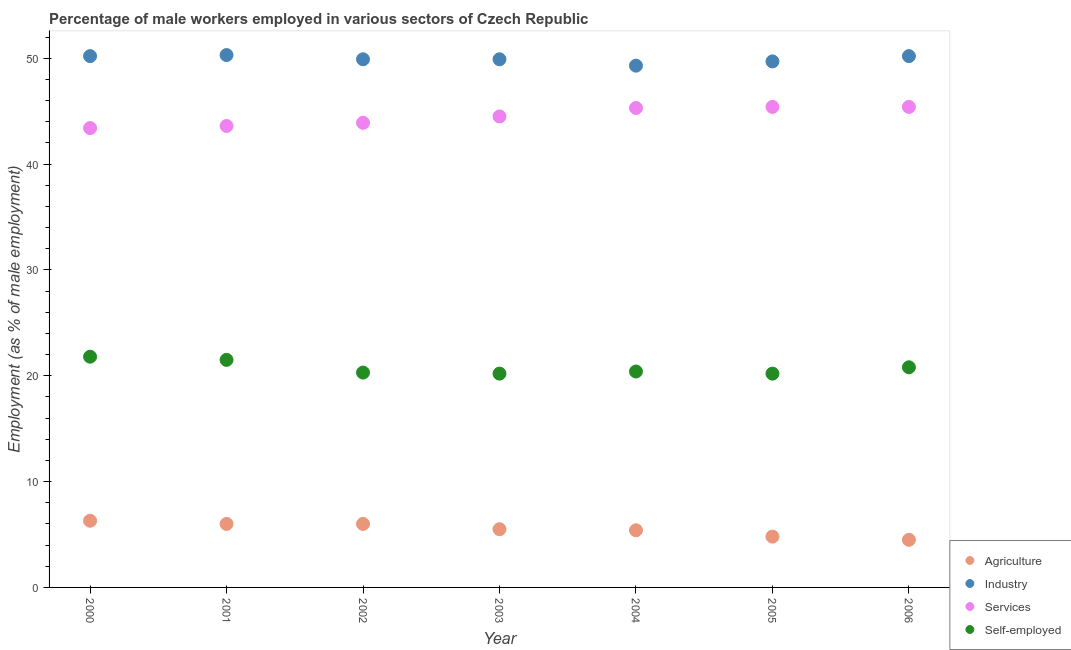What is the percentage of male workers in agriculture in 2005?
Provide a succinct answer. 4.8. Across all years, what is the maximum percentage of self employed male workers?
Provide a succinct answer. 21.8. Across all years, what is the minimum percentage of male workers in services?
Ensure brevity in your answer.  43.4. What is the total percentage of male workers in agriculture in the graph?
Your answer should be very brief. 38.5. What is the difference between the percentage of male workers in services in 2003 and the percentage of male workers in agriculture in 2001?
Provide a succinct answer. 38.5. What is the average percentage of male workers in industry per year?
Offer a terse response. 49.93. In the year 2001, what is the difference between the percentage of male workers in industry and percentage of self employed male workers?
Keep it short and to the point. 28.8. In how many years, is the percentage of male workers in agriculture greater than 32 %?
Make the answer very short. 0. What is the ratio of the percentage of male workers in services in 2001 to that in 2003?
Offer a very short reply. 0.98. Is the percentage of male workers in agriculture in 2000 less than that in 2005?
Your response must be concise. No. What is the difference between the highest and the second highest percentage of male workers in agriculture?
Offer a terse response. 0.3. What is the difference between the highest and the lowest percentage of self employed male workers?
Ensure brevity in your answer.  1.6. In how many years, is the percentage of self employed male workers greater than the average percentage of self employed male workers taken over all years?
Your answer should be very brief. 3. Does the percentage of male workers in industry monotonically increase over the years?
Your answer should be compact. No. Is the percentage of male workers in industry strictly less than the percentage of male workers in services over the years?
Offer a very short reply. No. How many dotlines are there?
Your response must be concise. 4. Are the values on the major ticks of Y-axis written in scientific E-notation?
Keep it short and to the point. No. Does the graph contain grids?
Provide a succinct answer. No. How many legend labels are there?
Give a very brief answer. 4. What is the title of the graph?
Your answer should be compact. Percentage of male workers employed in various sectors of Czech Republic. Does "Primary education" appear as one of the legend labels in the graph?
Give a very brief answer. No. What is the label or title of the Y-axis?
Offer a terse response. Employment (as % of male employment). What is the Employment (as % of male employment) in Agriculture in 2000?
Provide a short and direct response. 6.3. What is the Employment (as % of male employment) of Industry in 2000?
Your answer should be compact. 50.2. What is the Employment (as % of male employment) of Services in 2000?
Make the answer very short. 43.4. What is the Employment (as % of male employment) of Self-employed in 2000?
Provide a short and direct response. 21.8. What is the Employment (as % of male employment) of Industry in 2001?
Keep it short and to the point. 50.3. What is the Employment (as % of male employment) of Services in 2001?
Make the answer very short. 43.6. What is the Employment (as % of male employment) of Self-employed in 2001?
Give a very brief answer. 21.5. What is the Employment (as % of male employment) of Agriculture in 2002?
Keep it short and to the point. 6. What is the Employment (as % of male employment) of Industry in 2002?
Your answer should be compact. 49.9. What is the Employment (as % of male employment) in Services in 2002?
Provide a succinct answer. 43.9. What is the Employment (as % of male employment) of Self-employed in 2002?
Give a very brief answer. 20.3. What is the Employment (as % of male employment) of Agriculture in 2003?
Your response must be concise. 5.5. What is the Employment (as % of male employment) of Industry in 2003?
Keep it short and to the point. 49.9. What is the Employment (as % of male employment) in Services in 2003?
Ensure brevity in your answer.  44.5. What is the Employment (as % of male employment) of Self-employed in 2003?
Offer a terse response. 20.2. What is the Employment (as % of male employment) of Agriculture in 2004?
Your answer should be very brief. 5.4. What is the Employment (as % of male employment) of Industry in 2004?
Provide a short and direct response. 49.3. What is the Employment (as % of male employment) of Services in 2004?
Offer a terse response. 45.3. What is the Employment (as % of male employment) in Self-employed in 2004?
Make the answer very short. 20.4. What is the Employment (as % of male employment) of Agriculture in 2005?
Ensure brevity in your answer.  4.8. What is the Employment (as % of male employment) in Industry in 2005?
Offer a very short reply. 49.7. What is the Employment (as % of male employment) in Services in 2005?
Make the answer very short. 45.4. What is the Employment (as % of male employment) of Self-employed in 2005?
Offer a very short reply. 20.2. What is the Employment (as % of male employment) in Industry in 2006?
Offer a terse response. 50.2. What is the Employment (as % of male employment) of Services in 2006?
Your response must be concise. 45.4. What is the Employment (as % of male employment) in Self-employed in 2006?
Offer a very short reply. 20.8. Across all years, what is the maximum Employment (as % of male employment) of Agriculture?
Your response must be concise. 6.3. Across all years, what is the maximum Employment (as % of male employment) of Industry?
Offer a very short reply. 50.3. Across all years, what is the maximum Employment (as % of male employment) in Services?
Offer a terse response. 45.4. Across all years, what is the maximum Employment (as % of male employment) of Self-employed?
Provide a short and direct response. 21.8. Across all years, what is the minimum Employment (as % of male employment) in Agriculture?
Your answer should be very brief. 4.5. Across all years, what is the minimum Employment (as % of male employment) of Industry?
Your answer should be very brief. 49.3. Across all years, what is the minimum Employment (as % of male employment) in Services?
Your answer should be compact. 43.4. Across all years, what is the minimum Employment (as % of male employment) of Self-employed?
Offer a terse response. 20.2. What is the total Employment (as % of male employment) in Agriculture in the graph?
Your answer should be very brief. 38.5. What is the total Employment (as % of male employment) of Industry in the graph?
Provide a succinct answer. 349.5. What is the total Employment (as % of male employment) of Services in the graph?
Offer a terse response. 311.5. What is the total Employment (as % of male employment) of Self-employed in the graph?
Offer a terse response. 145.2. What is the difference between the Employment (as % of male employment) in Agriculture in 2000 and that in 2001?
Offer a terse response. 0.3. What is the difference between the Employment (as % of male employment) of Industry in 2000 and that in 2001?
Ensure brevity in your answer.  -0.1. What is the difference between the Employment (as % of male employment) in Services in 2000 and that in 2001?
Provide a short and direct response. -0.2. What is the difference between the Employment (as % of male employment) in Agriculture in 2000 and that in 2002?
Ensure brevity in your answer.  0.3. What is the difference between the Employment (as % of male employment) in Industry in 2000 and that in 2002?
Provide a succinct answer. 0.3. What is the difference between the Employment (as % of male employment) of Services in 2000 and that in 2002?
Your answer should be compact. -0.5. What is the difference between the Employment (as % of male employment) of Self-employed in 2000 and that in 2002?
Keep it short and to the point. 1.5. What is the difference between the Employment (as % of male employment) of Agriculture in 2000 and that in 2003?
Your response must be concise. 0.8. What is the difference between the Employment (as % of male employment) in Industry in 2000 and that in 2003?
Offer a terse response. 0.3. What is the difference between the Employment (as % of male employment) in Self-employed in 2000 and that in 2004?
Give a very brief answer. 1.4. What is the difference between the Employment (as % of male employment) in Agriculture in 2000 and that in 2005?
Your response must be concise. 1.5. What is the difference between the Employment (as % of male employment) of Services in 2000 and that in 2005?
Your response must be concise. -2. What is the difference between the Employment (as % of male employment) of Self-employed in 2000 and that in 2005?
Provide a short and direct response. 1.6. What is the difference between the Employment (as % of male employment) of Agriculture in 2000 and that in 2006?
Make the answer very short. 1.8. What is the difference between the Employment (as % of male employment) in Services in 2000 and that in 2006?
Offer a very short reply. -2. What is the difference between the Employment (as % of male employment) in Industry in 2001 and that in 2002?
Give a very brief answer. 0.4. What is the difference between the Employment (as % of male employment) of Services in 2001 and that in 2002?
Give a very brief answer. -0.3. What is the difference between the Employment (as % of male employment) in Self-employed in 2001 and that in 2002?
Keep it short and to the point. 1.2. What is the difference between the Employment (as % of male employment) in Agriculture in 2001 and that in 2004?
Give a very brief answer. 0.6. What is the difference between the Employment (as % of male employment) of Services in 2001 and that in 2005?
Give a very brief answer. -1.8. What is the difference between the Employment (as % of male employment) in Industry in 2001 and that in 2006?
Provide a succinct answer. 0.1. What is the difference between the Employment (as % of male employment) of Services in 2001 and that in 2006?
Make the answer very short. -1.8. What is the difference between the Employment (as % of male employment) of Agriculture in 2002 and that in 2003?
Offer a terse response. 0.5. What is the difference between the Employment (as % of male employment) of Industry in 2002 and that in 2004?
Offer a terse response. 0.6. What is the difference between the Employment (as % of male employment) in Self-employed in 2002 and that in 2004?
Your answer should be very brief. -0.1. What is the difference between the Employment (as % of male employment) in Agriculture in 2002 and that in 2005?
Provide a short and direct response. 1.2. What is the difference between the Employment (as % of male employment) in Services in 2002 and that in 2005?
Your response must be concise. -1.5. What is the difference between the Employment (as % of male employment) in Self-employed in 2002 and that in 2005?
Your answer should be very brief. 0.1. What is the difference between the Employment (as % of male employment) in Services in 2002 and that in 2006?
Give a very brief answer. -1.5. What is the difference between the Employment (as % of male employment) in Self-employed in 2002 and that in 2006?
Your answer should be very brief. -0.5. What is the difference between the Employment (as % of male employment) in Agriculture in 2003 and that in 2004?
Your response must be concise. 0.1. What is the difference between the Employment (as % of male employment) in Industry in 2003 and that in 2004?
Your answer should be very brief. 0.6. What is the difference between the Employment (as % of male employment) in Services in 2003 and that in 2004?
Your answer should be compact. -0.8. What is the difference between the Employment (as % of male employment) in Self-employed in 2003 and that in 2004?
Your answer should be very brief. -0.2. What is the difference between the Employment (as % of male employment) of Agriculture in 2003 and that in 2005?
Offer a very short reply. 0.7. What is the difference between the Employment (as % of male employment) in Self-employed in 2003 and that in 2005?
Ensure brevity in your answer.  0. What is the difference between the Employment (as % of male employment) of Services in 2003 and that in 2006?
Provide a succinct answer. -0.9. What is the difference between the Employment (as % of male employment) of Self-employed in 2003 and that in 2006?
Ensure brevity in your answer.  -0.6. What is the difference between the Employment (as % of male employment) in Agriculture in 2004 and that in 2005?
Give a very brief answer. 0.6. What is the difference between the Employment (as % of male employment) of Industry in 2004 and that in 2005?
Your response must be concise. -0.4. What is the difference between the Employment (as % of male employment) in Self-employed in 2004 and that in 2005?
Your response must be concise. 0.2. What is the difference between the Employment (as % of male employment) in Agriculture in 2004 and that in 2006?
Keep it short and to the point. 0.9. What is the difference between the Employment (as % of male employment) in Self-employed in 2004 and that in 2006?
Make the answer very short. -0.4. What is the difference between the Employment (as % of male employment) of Agriculture in 2005 and that in 2006?
Offer a very short reply. 0.3. What is the difference between the Employment (as % of male employment) of Industry in 2005 and that in 2006?
Offer a very short reply. -0.5. What is the difference between the Employment (as % of male employment) in Agriculture in 2000 and the Employment (as % of male employment) in Industry in 2001?
Your answer should be very brief. -44. What is the difference between the Employment (as % of male employment) in Agriculture in 2000 and the Employment (as % of male employment) in Services in 2001?
Offer a very short reply. -37.3. What is the difference between the Employment (as % of male employment) in Agriculture in 2000 and the Employment (as % of male employment) in Self-employed in 2001?
Your response must be concise. -15.2. What is the difference between the Employment (as % of male employment) of Industry in 2000 and the Employment (as % of male employment) of Services in 2001?
Your answer should be very brief. 6.6. What is the difference between the Employment (as % of male employment) of Industry in 2000 and the Employment (as % of male employment) of Self-employed in 2001?
Give a very brief answer. 28.7. What is the difference between the Employment (as % of male employment) of Services in 2000 and the Employment (as % of male employment) of Self-employed in 2001?
Keep it short and to the point. 21.9. What is the difference between the Employment (as % of male employment) of Agriculture in 2000 and the Employment (as % of male employment) of Industry in 2002?
Offer a very short reply. -43.6. What is the difference between the Employment (as % of male employment) in Agriculture in 2000 and the Employment (as % of male employment) in Services in 2002?
Ensure brevity in your answer.  -37.6. What is the difference between the Employment (as % of male employment) in Agriculture in 2000 and the Employment (as % of male employment) in Self-employed in 2002?
Provide a succinct answer. -14. What is the difference between the Employment (as % of male employment) in Industry in 2000 and the Employment (as % of male employment) in Self-employed in 2002?
Your answer should be compact. 29.9. What is the difference between the Employment (as % of male employment) in Services in 2000 and the Employment (as % of male employment) in Self-employed in 2002?
Give a very brief answer. 23.1. What is the difference between the Employment (as % of male employment) in Agriculture in 2000 and the Employment (as % of male employment) in Industry in 2003?
Provide a short and direct response. -43.6. What is the difference between the Employment (as % of male employment) in Agriculture in 2000 and the Employment (as % of male employment) in Services in 2003?
Ensure brevity in your answer.  -38.2. What is the difference between the Employment (as % of male employment) of Industry in 2000 and the Employment (as % of male employment) of Services in 2003?
Make the answer very short. 5.7. What is the difference between the Employment (as % of male employment) in Services in 2000 and the Employment (as % of male employment) in Self-employed in 2003?
Provide a short and direct response. 23.2. What is the difference between the Employment (as % of male employment) in Agriculture in 2000 and the Employment (as % of male employment) in Industry in 2004?
Ensure brevity in your answer.  -43. What is the difference between the Employment (as % of male employment) of Agriculture in 2000 and the Employment (as % of male employment) of Services in 2004?
Keep it short and to the point. -39. What is the difference between the Employment (as % of male employment) in Agriculture in 2000 and the Employment (as % of male employment) in Self-employed in 2004?
Your answer should be very brief. -14.1. What is the difference between the Employment (as % of male employment) in Industry in 2000 and the Employment (as % of male employment) in Services in 2004?
Ensure brevity in your answer.  4.9. What is the difference between the Employment (as % of male employment) of Industry in 2000 and the Employment (as % of male employment) of Self-employed in 2004?
Offer a terse response. 29.8. What is the difference between the Employment (as % of male employment) of Services in 2000 and the Employment (as % of male employment) of Self-employed in 2004?
Make the answer very short. 23. What is the difference between the Employment (as % of male employment) of Agriculture in 2000 and the Employment (as % of male employment) of Industry in 2005?
Make the answer very short. -43.4. What is the difference between the Employment (as % of male employment) of Agriculture in 2000 and the Employment (as % of male employment) of Services in 2005?
Offer a very short reply. -39.1. What is the difference between the Employment (as % of male employment) in Agriculture in 2000 and the Employment (as % of male employment) in Self-employed in 2005?
Give a very brief answer. -13.9. What is the difference between the Employment (as % of male employment) in Industry in 2000 and the Employment (as % of male employment) in Self-employed in 2005?
Provide a succinct answer. 30. What is the difference between the Employment (as % of male employment) of Services in 2000 and the Employment (as % of male employment) of Self-employed in 2005?
Provide a succinct answer. 23.2. What is the difference between the Employment (as % of male employment) of Agriculture in 2000 and the Employment (as % of male employment) of Industry in 2006?
Offer a terse response. -43.9. What is the difference between the Employment (as % of male employment) in Agriculture in 2000 and the Employment (as % of male employment) in Services in 2006?
Your response must be concise. -39.1. What is the difference between the Employment (as % of male employment) in Industry in 2000 and the Employment (as % of male employment) in Services in 2006?
Your answer should be very brief. 4.8. What is the difference between the Employment (as % of male employment) in Industry in 2000 and the Employment (as % of male employment) in Self-employed in 2006?
Your response must be concise. 29.4. What is the difference between the Employment (as % of male employment) in Services in 2000 and the Employment (as % of male employment) in Self-employed in 2006?
Give a very brief answer. 22.6. What is the difference between the Employment (as % of male employment) of Agriculture in 2001 and the Employment (as % of male employment) of Industry in 2002?
Your answer should be compact. -43.9. What is the difference between the Employment (as % of male employment) in Agriculture in 2001 and the Employment (as % of male employment) in Services in 2002?
Provide a succinct answer. -37.9. What is the difference between the Employment (as % of male employment) in Agriculture in 2001 and the Employment (as % of male employment) in Self-employed in 2002?
Offer a terse response. -14.3. What is the difference between the Employment (as % of male employment) of Industry in 2001 and the Employment (as % of male employment) of Services in 2002?
Ensure brevity in your answer.  6.4. What is the difference between the Employment (as % of male employment) in Industry in 2001 and the Employment (as % of male employment) in Self-employed in 2002?
Offer a very short reply. 30. What is the difference between the Employment (as % of male employment) of Services in 2001 and the Employment (as % of male employment) of Self-employed in 2002?
Give a very brief answer. 23.3. What is the difference between the Employment (as % of male employment) of Agriculture in 2001 and the Employment (as % of male employment) of Industry in 2003?
Provide a succinct answer. -43.9. What is the difference between the Employment (as % of male employment) in Agriculture in 2001 and the Employment (as % of male employment) in Services in 2003?
Ensure brevity in your answer.  -38.5. What is the difference between the Employment (as % of male employment) in Agriculture in 2001 and the Employment (as % of male employment) in Self-employed in 2003?
Your answer should be very brief. -14.2. What is the difference between the Employment (as % of male employment) of Industry in 2001 and the Employment (as % of male employment) of Services in 2003?
Offer a terse response. 5.8. What is the difference between the Employment (as % of male employment) of Industry in 2001 and the Employment (as % of male employment) of Self-employed in 2003?
Your answer should be very brief. 30.1. What is the difference between the Employment (as % of male employment) in Services in 2001 and the Employment (as % of male employment) in Self-employed in 2003?
Make the answer very short. 23.4. What is the difference between the Employment (as % of male employment) of Agriculture in 2001 and the Employment (as % of male employment) of Industry in 2004?
Ensure brevity in your answer.  -43.3. What is the difference between the Employment (as % of male employment) in Agriculture in 2001 and the Employment (as % of male employment) in Services in 2004?
Give a very brief answer. -39.3. What is the difference between the Employment (as % of male employment) of Agriculture in 2001 and the Employment (as % of male employment) of Self-employed in 2004?
Your answer should be very brief. -14.4. What is the difference between the Employment (as % of male employment) of Industry in 2001 and the Employment (as % of male employment) of Services in 2004?
Your response must be concise. 5. What is the difference between the Employment (as % of male employment) in Industry in 2001 and the Employment (as % of male employment) in Self-employed in 2004?
Make the answer very short. 29.9. What is the difference between the Employment (as % of male employment) in Services in 2001 and the Employment (as % of male employment) in Self-employed in 2004?
Your response must be concise. 23.2. What is the difference between the Employment (as % of male employment) in Agriculture in 2001 and the Employment (as % of male employment) in Industry in 2005?
Keep it short and to the point. -43.7. What is the difference between the Employment (as % of male employment) of Agriculture in 2001 and the Employment (as % of male employment) of Services in 2005?
Your answer should be compact. -39.4. What is the difference between the Employment (as % of male employment) of Agriculture in 2001 and the Employment (as % of male employment) of Self-employed in 2005?
Provide a succinct answer. -14.2. What is the difference between the Employment (as % of male employment) of Industry in 2001 and the Employment (as % of male employment) of Services in 2005?
Your answer should be very brief. 4.9. What is the difference between the Employment (as % of male employment) of Industry in 2001 and the Employment (as % of male employment) of Self-employed in 2005?
Offer a terse response. 30.1. What is the difference between the Employment (as % of male employment) of Services in 2001 and the Employment (as % of male employment) of Self-employed in 2005?
Provide a short and direct response. 23.4. What is the difference between the Employment (as % of male employment) of Agriculture in 2001 and the Employment (as % of male employment) of Industry in 2006?
Make the answer very short. -44.2. What is the difference between the Employment (as % of male employment) in Agriculture in 2001 and the Employment (as % of male employment) in Services in 2006?
Provide a short and direct response. -39.4. What is the difference between the Employment (as % of male employment) of Agriculture in 2001 and the Employment (as % of male employment) of Self-employed in 2006?
Provide a short and direct response. -14.8. What is the difference between the Employment (as % of male employment) of Industry in 2001 and the Employment (as % of male employment) of Self-employed in 2006?
Keep it short and to the point. 29.5. What is the difference between the Employment (as % of male employment) in Services in 2001 and the Employment (as % of male employment) in Self-employed in 2006?
Offer a terse response. 22.8. What is the difference between the Employment (as % of male employment) of Agriculture in 2002 and the Employment (as % of male employment) of Industry in 2003?
Provide a short and direct response. -43.9. What is the difference between the Employment (as % of male employment) of Agriculture in 2002 and the Employment (as % of male employment) of Services in 2003?
Keep it short and to the point. -38.5. What is the difference between the Employment (as % of male employment) in Industry in 2002 and the Employment (as % of male employment) in Services in 2003?
Ensure brevity in your answer.  5.4. What is the difference between the Employment (as % of male employment) in Industry in 2002 and the Employment (as % of male employment) in Self-employed in 2003?
Give a very brief answer. 29.7. What is the difference between the Employment (as % of male employment) in Services in 2002 and the Employment (as % of male employment) in Self-employed in 2003?
Offer a terse response. 23.7. What is the difference between the Employment (as % of male employment) in Agriculture in 2002 and the Employment (as % of male employment) in Industry in 2004?
Give a very brief answer. -43.3. What is the difference between the Employment (as % of male employment) of Agriculture in 2002 and the Employment (as % of male employment) of Services in 2004?
Offer a terse response. -39.3. What is the difference between the Employment (as % of male employment) of Agriculture in 2002 and the Employment (as % of male employment) of Self-employed in 2004?
Your answer should be compact. -14.4. What is the difference between the Employment (as % of male employment) in Industry in 2002 and the Employment (as % of male employment) in Self-employed in 2004?
Offer a terse response. 29.5. What is the difference between the Employment (as % of male employment) of Agriculture in 2002 and the Employment (as % of male employment) of Industry in 2005?
Your response must be concise. -43.7. What is the difference between the Employment (as % of male employment) of Agriculture in 2002 and the Employment (as % of male employment) of Services in 2005?
Make the answer very short. -39.4. What is the difference between the Employment (as % of male employment) of Agriculture in 2002 and the Employment (as % of male employment) of Self-employed in 2005?
Your answer should be compact. -14.2. What is the difference between the Employment (as % of male employment) of Industry in 2002 and the Employment (as % of male employment) of Services in 2005?
Offer a terse response. 4.5. What is the difference between the Employment (as % of male employment) of Industry in 2002 and the Employment (as % of male employment) of Self-employed in 2005?
Your response must be concise. 29.7. What is the difference between the Employment (as % of male employment) in Services in 2002 and the Employment (as % of male employment) in Self-employed in 2005?
Give a very brief answer. 23.7. What is the difference between the Employment (as % of male employment) in Agriculture in 2002 and the Employment (as % of male employment) in Industry in 2006?
Your answer should be compact. -44.2. What is the difference between the Employment (as % of male employment) of Agriculture in 2002 and the Employment (as % of male employment) of Services in 2006?
Keep it short and to the point. -39.4. What is the difference between the Employment (as % of male employment) in Agriculture in 2002 and the Employment (as % of male employment) in Self-employed in 2006?
Your answer should be compact. -14.8. What is the difference between the Employment (as % of male employment) in Industry in 2002 and the Employment (as % of male employment) in Self-employed in 2006?
Make the answer very short. 29.1. What is the difference between the Employment (as % of male employment) of Services in 2002 and the Employment (as % of male employment) of Self-employed in 2006?
Your answer should be compact. 23.1. What is the difference between the Employment (as % of male employment) of Agriculture in 2003 and the Employment (as % of male employment) of Industry in 2004?
Offer a very short reply. -43.8. What is the difference between the Employment (as % of male employment) in Agriculture in 2003 and the Employment (as % of male employment) in Services in 2004?
Provide a short and direct response. -39.8. What is the difference between the Employment (as % of male employment) in Agriculture in 2003 and the Employment (as % of male employment) in Self-employed in 2004?
Make the answer very short. -14.9. What is the difference between the Employment (as % of male employment) in Industry in 2003 and the Employment (as % of male employment) in Self-employed in 2004?
Offer a very short reply. 29.5. What is the difference between the Employment (as % of male employment) of Services in 2003 and the Employment (as % of male employment) of Self-employed in 2004?
Offer a terse response. 24.1. What is the difference between the Employment (as % of male employment) of Agriculture in 2003 and the Employment (as % of male employment) of Industry in 2005?
Offer a very short reply. -44.2. What is the difference between the Employment (as % of male employment) in Agriculture in 2003 and the Employment (as % of male employment) in Services in 2005?
Your answer should be compact. -39.9. What is the difference between the Employment (as % of male employment) of Agriculture in 2003 and the Employment (as % of male employment) of Self-employed in 2005?
Your answer should be compact. -14.7. What is the difference between the Employment (as % of male employment) in Industry in 2003 and the Employment (as % of male employment) in Self-employed in 2005?
Give a very brief answer. 29.7. What is the difference between the Employment (as % of male employment) in Services in 2003 and the Employment (as % of male employment) in Self-employed in 2005?
Give a very brief answer. 24.3. What is the difference between the Employment (as % of male employment) of Agriculture in 2003 and the Employment (as % of male employment) of Industry in 2006?
Your answer should be compact. -44.7. What is the difference between the Employment (as % of male employment) of Agriculture in 2003 and the Employment (as % of male employment) of Services in 2006?
Keep it short and to the point. -39.9. What is the difference between the Employment (as % of male employment) in Agriculture in 2003 and the Employment (as % of male employment) in Self-employed in 2006?
Ensure brevity in your answer.  -15.3. What is the difference between the Employment (as % of male employment) in Industry in 2003 and the Employment (as % of male employment) in Services in 2006?
Give a very brief answer. 4.5. What is the difference between the Employment (as % of male employment) in Industry in 2003 and the Employment (as % of male employment) in Self-employed in 2006?
Make the answer very short. 29.1. What is the difference between the Employment (as % of male employment) in Services in 2003 and the Employment (as % of male employment) in Self-employed in 2006?
Ensure brevity in your answer.  23.7. What is the difference between the Employment (as % of male employment) of Agriculture in 2004 and the Employment (as % of male employment) of Industry in 2005?
Your answer should be compact. -44.3. What is the difference between the Employment (as % of male employment) in Agriculture in 2004 and the Employment (as % of male employment) in Self-employed in 2005?
Keep it short and to the point. -14.8. What is the difference between the Employment (as % of male employment) in Industry in 2004 and the Employment (as % of male employment) in Services in 2005?
Make the answer very short. 3.9. What is the difference between the Employment (as % of male employment) of Industry in 2004 and the Employment (as % of male employment) of Self-employed in 2005?
Offer a very short reply. 29.1. What is the difference between the Employment (as % of male employment) in Services in 2004 and the Employment (as % of male employment) in Self-employed in 2005?
Your response must be concise. 25.1. What is the difference between the Employment (as % of male employment) of Agriculture in 2004 and the Employment (as % of male employment) of Industry in 2006?
Your answer should be very brief. -44.8. What is the difference between the Employment (as % of male employment) in Agriculture in 2004 and the Employment (as % of male employment) in Self-employed in 2006?
Provide a succinct answer. -15.4. What is the difference between the Employment (as % of male employment) of Industry in 2004 and the Employment (as % of male employment) of Self-employed in 2006?
Your answer should be very brief. 28.5. What is the difference between the Employment (as % of male employment) in Services in 2004 and the Employment (as % of male employment) in Self-employed in 2006?
Keep it short and to the point. 24.5. What is the difference between the Employment (as % of male employment) in Agriculture in 2005 and the Employment (as % of male employment) in Industry in 2006?
Offer a terse response. -45.4. What is the difference between the Employment (as % of male employment) in Agriculture in 2005 and the Employment (as % of male employment) in Services in 2006?
Keep it short and to the point. -40.6. What is the difference between the Employment (as % of male employment) in Agriculture in 2005 and the Employment (as % of male employment) in Self-employed in 2006?
Provide a short and direct response. -16. What is the difference between the Employment (as % of male employment) of Industry in 2005 and the Employment (as % of male employment) of Services in 2006?
Offer a terse response. 4.3. What is the difference between the Employment (as % of male employment) of Industry in 2005 and the Employment (as % of male employment) of Self-employed in 2006?
Your response must be concise. 28.9. What is the difference between the Employment (as % of male employment) of Services in 2005 and the Employment (as % of male employment) of Self-employed in 2006?
Keep it short and to the point. 24.6. What is the average Employment (as % of male employment) of Industry per year?
Your response must be concise. 49.93. What is the average Employment (as % of male employment) of Services per year?
Provide a short and direct response. 44.5. What is the average Employment (as % of male employment) in Self-employed per year?
Give a very brief answer. 20.74. In the year 2000, what is the difference between the Employment (as % of male employment) of Agriculture and Employment (as % of male employment) of Industry?
Make the answer very short. -43.9. In the year 2000, what is the difference between the Employment (as % of male employment) of Agriculture and Employment (as % of male employment) of Services?
Ensure brevity in your answer.  -37.1. In the year 2000, what is the difference between the Employment (as % of male employment) in Agriculture and Employment (as % of male employment) in Self-employed?
Provide a short and direct response. -15.5. In the year 2000, what is the difference between the Employment (as % of male employment) in Industry and Employment (as % of male employment) in Self-employed?
Provide a succinct answer. 28.4. In the year 2000, what is the difference between the Employment (as % of male employment) in Services and Employment (as % of male employment) in Self-employed?
Provide a short and direct response. 21.6. In the year 2001, what is the difference between the Employment (as % of male employment) in Agriculture and Employment (as % of male employment) in Industry?
Provide a short and direct response. -44.3. In the year 2001, what is the difference between the Employment (as % of male employment) of Agriculture and Employment (as % of male employment) of Services?
Offer a very short reply. -37.6. In the year 2001, what is the difference between the Employment (as % of male employment) of Agriculture and Employment (as % of male employment) of Self-employed?
Offer a very short reply. -15.5. In the year 2001, what is the difference between the Employment (as % of male employment) in Industry and Employment (as % of male employment) in Self-employed?
Provide a short and direct response. 28.8. In the year 2001, what is the difference between the Employment (as % of male employment) of Services and Employment (as % of male employment) of Self-employed?
Provide a succinct answer. 22.1. In the year 2002, what is the difference between the Employment (as % of male employment) in Agriculture and Employment (as % of male employment) in Industry?
Offer a terse response. -43.9. In the year 2002, what is the difference between the Employment (as % of male employment) of Agriculture and Employment (as % of male employment) of Services?
Your answer should be compact. -37.9. In the year 2002, what is the difference between the Employment (as % of male employment) in Agriculture and Employment (as % of male employment) in Self-employed?
Ensure brevity in your answer.  -14.3. In the year 2002, what is the difference between the Employment (as % of male employment) in Industry and Employment (as % of male employment) in Services?
Your answer should be compact. 6. In the year 2002, what is the difference between the Employment (as % of male employment) in Industry and Employment (as % of male employment) in Self-employed?
Your answer should be very brief. 29.6. In the year 2002, what is the difference between the Employment (as % of male employment) of Services and Employment (as % of male employment) of Self-employed?
Your response must be concise. 23.6. In the year 2003, what is the difference between the Employment (as % of male employment) in Agriculture and Employment (as % of male employment) in Industry?
Keep it short and to the point. -44.4. In the year 2003, what is the difference between the Employment (as % of male employment) of Agriculture and Employment (as % of male employment) of Services?
Your response must be concise. -39. In the year 2003, what is the difference between the Employment (as % of male employment) of Agriculture and Employment (as % of male employment) of Self-employed?
Your answer should be very brief. -14.7. In the year 2003, what is the difference between the Employment (as % of male employment) of Industry and Employment (as % of male employment) of Services?
Make the answer very short. 5.4. In the year 2003, what is the difference between the Employment (as % of male employment) of Industry and Employment (as % of male employment) of Self-employed?
Keep it short and to the point. 29.7. In the year 2003, what is the difference between the Employment (as % of male employment) of Services and Employment (as % of male employment) of Self-employed?
Offer a terse response. 24.3. In the year 2004, what is the difference between the Employment (as % of male employment) of Agriculture and Employment (as % of male employment) of Industry?
Offer a very short reply. -43.9. In the year 2004, what is the difference between the Employment (as % of male employment) of Agriculture and Employment (as % of male employment) of Services?
Offer a terse response. -39.9. In the year 2004, what is the difference between the Employment (as % of male employment) of Agriculture and Employment (as % of male employment) of Self-employed?
Provide a succinct answer. -15. In the year 2004, what is the difference between the Employment (as % of male employment) in Industry and Employment (as % of male employment) in Services?
Your answer should be very brief. 4. In the year 2004, what is the difference between the Employment (as % of male employment) in Industry and Employment (as % of male employment) in Self-employed?
Keep it short and to the point. 28.9. In the year 2004, what is the difference between the Employment (as % of male employment) in Services and Employment (as % of male employment) in Self-employed?
Make the answer very short. 24.9. In the year 2005, what is the difference between the Employment (as % of male employment) in Agriculture and Employment (as % of male employment) in Industry?
Your answer should be compact. -44.9. In the year 2005, what is the difference between the Employment (as % of male employment) in Agriculture and Employment (as % of male employment) in Services?
Your answer should be compact. -40.6. In the year 2005, what is the difference between the Employment (as % of male employment) in Agriculture and Employment (as % of male employment) in Self-employed?
Your response must be concise. -15.4. In the year 2005, what is the difference between the Employment (as % of male employment) of Industry and Employment (as % of male employment) of Services?
Provide a succinct answer. 4.3. In the year 2005, what is the difference between the Employment (as % of male employment) in Industry and Employment (as % of male employment) in Self-employed?
Provide a short and direct response. 29.5. In the year 2005, what is the difference between the Employment (as % of male employment) in Services and Employment (as % of male employment) in Self-employed?
Provide a short and direct response. 25.2. In the year 2006, what is the difference between the Employment (as % of male employment) in Agriculture and Employment (as % of male employment) in Industry?
Offer a very short reply. -45.7. In the year 2006, what is the difference between the Employment (as % of male employment) in Agriculture and Employment (as % of male employment) in Services?
Ensure brevity in your answer.  -40.9. In the year 2006, what is the difference between the Employment (as % of male employment) in Agriculture and Employment (as % of male employment) in Self-employed?
Offer a very short reply. -16.3. In the year 2006, what is the difference between the Employment (as % of male employment) of Industry and Employment (as % of male employment) of Services?
Your answer should be very brief. 4.8. In the year 2006, what is the difference between the Employment (as % of male employment) in Industry and Employment (as % of male employment) in Self-employed?
Your response must be concise. 29.4. In the year 2006, what is the difference between the Employment (as % of male employment) in Services and Employment (as % of male employment) in Self-employed?
Your answer should be very brief. 24.6. What is the ratio of the Employment (as % of male employment) in Agriculture in 2000 to that in 2001?
Offer a very short reply. 1.05. What is the ratio of the Employment (as % of male employment) of Services in 2000 to that in 2002?
Your answer should be very brief. 0.99. What is the ratio of the Employment (as % of male employment) of Self-employed in 2000 to that in 2002?
Make the answer very short. 1.07. What is the ratio of the Employment (as % of male employment) in Agriculture in 2000 to that in 2003?
Ensure brevity in your answer.  1.15. What is the ratio of the Employment (as % of male employment) in Services in 2000 to that in 2003?
Offer a very short reply. 0.98. What is the ratio of the Employment (as % of male employment) in Self-employed in 2000 to that in 2003?
Keep it short and to the point. 1.08. What is the ratio of the Employment (as % of male employment) in Industry in 2000 to that in 2004?
Your answer should be compact. 1.02. What is the ratio of the Employment (as % of male employment) in Services in 2000 to that in 2004?
Keep it short and to the point. 0.96. What is the ratio of the Employment (as % of male employment) in Self-employed in 2000 to that in 2004?
Provide a short and direct response. 1.07. What is the ratio of the Employment (as % of male employment) in Agriculture in 2000 to that in 2005?
Provide a succinct answer. 1.31. What is the ratio of the Employment (as % of male employment) in Services in 2000 to that in 2005?
Provide a short and direct response. 0.96. What is the ratio of the Employment (as % of male employment) in Self-employed in 2000 to that in 2005?
Your response must be concise. 1.08. What is the ratio of the Employment (as % of male employment) in Agriculture in 2000 to that in 2006?
Offer a very short reply. 1.4. What is the ratio of the Employment (as % of male employment) in Services in 2000 to that in 2006?
Your response must be concise. 0.96. What is the ratio of the Employment (as % of male employment) in Self-employed in 2000 to that in 2006?
Ensure brevity in your answer.  1.05. What is the ratio of the Employment (as % of male employment) in Industry in 2001 to that in 2002?
Offer a terse response. 1.01. What is the ratio of the Employment (as % of male employment) in Self-employed in 2001 to that in 2002?
Your answer should be compact. 1.06. What is the ratio of the Employment (as % of male employment) in Industry in 2001 to that in 2003?
Your response must be concise. 1.01. What is the ratio of the Employment (as % of male employment) of Services in 2001 to that in 2003?
Your response must be concise. 0.98. What is the ratio of the Employment (as % of male employment) in Self-employed in 2001 to that in 2003?
Your answer should be very brief. 1.06. What is the ratio of the Employment (as % of male employment) in Industry in 2001 to that in 2004?
Offer a very short reply. 1.02. What is the ratio of the Employment (as % of male employment) of Services in 2001 to that in 2004?
Provide a succinct answer. 0.96. What is the ratio of the Employment (as % of male employment) of Self-employed in 2001 to that in 2004?
Offer a terse response. 1.05. What is the ratio of the Employment (as % of male employment) of Industry in 2001 to that in 2005?
Provide a short and direct response. 1.01. What is the ratio of the Employment (as % of male employment) of Services in 2001 to that in 2005?
Your answer should be compact. 0.96. What is the ratio of the Employment (as % of male employment) of Self-employed in 2001 to that in 2005?
Ensure brevity in your answer.  1.06. What is the ratio of the Employment (as % of male employment) in Agriculture in 2001 to that in 2006?
Your answer should be compact. 1.33. What is the ratio of the Employment (as % of male employment) in Industry in 2001 to that in 2006?
Give a very brief answer. 1. What is the ratio of the Employment (as % of male employment) in Services in 2001 to that in 2006?
Give a very brief answer. 0.96. What is the ratio of the Employment (as % of male employment) of Self-employed in 2001 to that in 2006?
Offer a very short reply. 1.03. What is the ratio of the Employment (as % of male employment) of Agriculture in 2002 to that in 2003?
Keep it short and to the point. 1.09. What is the ratio of the Employment (as % of male employment) of Industry in 2002 to that in 2003?
Keep it short and to the point. 1. What is the ratio of the Employment (as % of male employment) in Services in 2002 to that in 2003?
Keep it short and to the point. 0.99. What is the ratio of the Employment (as % of male employment) of Self-employed in 2002 to that in 2003?
Offer a very short reply. 1. What is the ratio of the Employment (as % of male employment) of Industry in 2002 to that in 2004?
Offer a terse response. 1.01. What is the ratio of the Employment (as % of male employment) in Services in 2002 to that in 2004?
Provide a short and direct response. 0.97. What is the ratio of the Employment (as % of male employment) in Services in 2002 to that in 2005?
Your answer should be compact. 0.97. What is the ratio of the Employment (as % of male employment) in Self-employed in 2002 to that in 2005?
Your response must be concise. 1. What is the ratio of the Employment (as % of male employment) of Agriculture in 2002 to that in 2006?
Your answer should be very brief. 1.33. What is the ratio of the Employment (as % of male employment) of Services in 2002 to that in 2006?
Give a very brief answer. 0.97. What is the ratio of the Employment (as % of male employment) of Self-employed in 2002 to that in 2006?
Offer a terse response. 0.98. What is the ratio of the Employment (as % of male employment) of Agriculture in 2003 to that in 2004?
Provide a short and direct response. 1.02. What is the ratio of the Employment (as % of male employment) in Industry in 2003 to that in 2004?
Your answer should be very brief. 1.01. What is the ratio of the Employment (as % of male employment) of Services in 2003 to that in 2004?
Provide a short and direct response. 0.98. What is the ratio of the Employment (as % of male employment) of Self-employed in 2003 to that in 2004?
Provide a succinct answer. 0.99. What is the ratio of the Employment (as % of male employment) of Agriculture in 2003 to that in 2005?
Offer a very short reply. 1.15. What is the ratio of the Employment (as % of male employment) of Industry in 2003 to that in 2005?
Provide a short and direct response. 1. What is the ratio of the Employment (as % of male employment) of Services in 2003 to that in 2005?
Your response must be concise. 0.98. What is the ratio of the Employment (as % of male employment) in Agriculture in 2003 to that in 2006?
Ensure brevity in your answer.  1.22. What is the ratio of the Employment (as % of male employment) of Industry in 2003 to that in 2006?
Your response must be concise. 0.99. What is the ratio of the Employment (as % of male employment) of Services in 2003 to that in 2006?
Ensure brevity in your answer.  0.98. What is the ratio of the Employment (as % of male employment) of Self-employed in 2003 to that in 2006?
Offer a terse response. 0.97. What is the ratio of the Employment (as % of male employment) in Agriculture in 2004 to that in 2005?
Provide a succinct answer. 1.12. What is the ratio of the Employment (as % of male employment) of Self-employed in 2004 to that in 2005?
Make the answer very short. 1.01. What is the ratio of the Employment (as % of male employment) in Agriculture in 2004 to that in 2006?
Keep it short and to the point. 1.2. What is the ratio of the Employment (as % of male employment) of Industry in 2004 to that in 2006?
Provide a succinct answer. 0.98. What is the ratio of the Employment (as % of male employment) of Services in 2004 to that in 2006?
Provide a succinct answer. 1. What is the ratio of the Employment (as % of male employment) of Self-employed in 2004 to that in 2006?
Provide a short and direct response. 0.98. What is the ratio of the Employment (as % of male employment) in Agriculture in 2005 to that in 2006?
Ensure brevity in your answer.  1.07. What is the ratio of the Employment (as % of male employment) of Industry in 2005 to that in 2006?
Offer a terse response. 0.99. What is the ratio of the Employment (as % of male employment) of Services in 2005 to that in 2006?
Offer a terse response. 1. What is the ratio of the Employment (as % of male employment) of Self-employed in 2005 to that in 2006?
Make the answer very short. 0.97. What is the difference between the highest and the second highest Employment (as % of male employment) of Agriculture?
Your answer should be very brief. 0.3. What is the difference between the highest and the second highest Employment (as % of male employment) in Industry?
Offer a terse response. 0.1. What is the difference between the highest and the second highest Employment (as % of male employment) in Services?
Provide a short and direct response. 0. What is the difference between the highest and the lowest Employment (as % of male employment) of Industry?
Give a very brief answer. 1. 